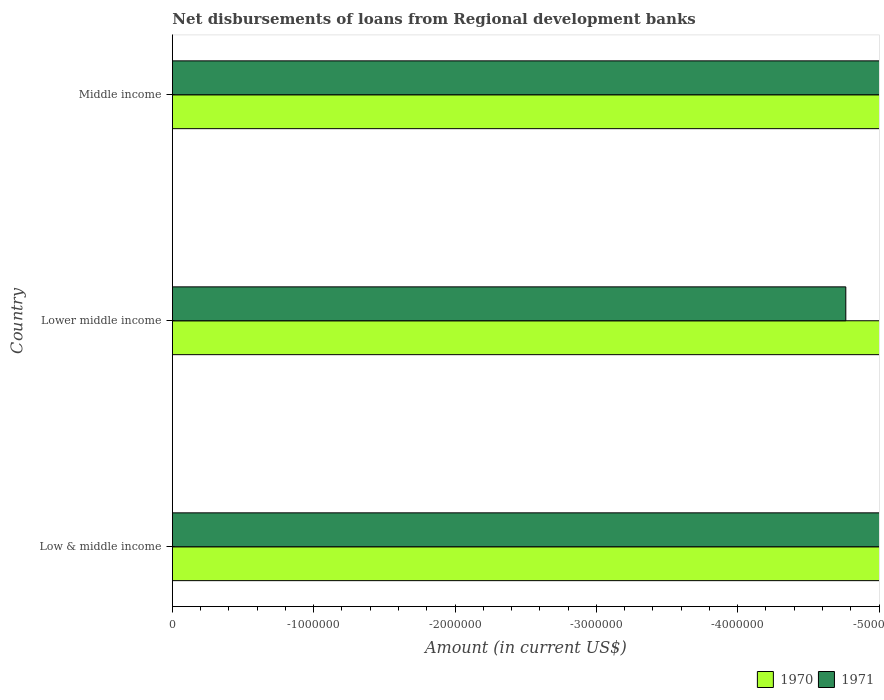How many different coloured bars are there?
Ensure brevity in your answer.  0. Are the number of bars per tick equal to the number of legend labels?
Offer a very short reply. No. How many bars are there on the 1st tick from the top?
Offer a very short reply. 0. What is the label of the 1st group of bars from the top?
Offer a very short reply. Middle income. What is the amount of disbursements of loans from regional development banks in 1970 in Middle income?
Your answer should be compact. 0. What is the difference between the amount of disbursements of loans from regional development banks in 1971 in Lower middle income and the amount of disbursements of loans from regional development banks in 1970 in Low & middle income?
Offer a terse response. 0. In how many countries, is the amount of disbursements of loans from regional development banks in 1971 greater than the average amount of disbursements of loans from regional development banks in 1971 taken over all countries?
Provide a succinct answer. 0. How many countries are there in the graph?
Give a very brief answer. 3. Does the graph contain any zero values?
Your response must be concise. Yes. Does the graph contain grids?
Make the answer very short. No. How many legend labels are there?
Provide a succinct answer. 2. How are the legend labels stacked?
Provide a short and direct response. Horizontal. What is the title of the graph?
Your response must be concise. Net disbursements of loans from Regional development banks. What is the label or title of the X-axis?
Give a very brief answer. Amount (in current US$). What is the label or title of the Y-axis?
Keep it short and to the point. Country. What is the Amount (in current US$) of 1970 in Low & middle income?
Ensure brevity in your answer.  0. What is the Amount (in current US$) of 1970 in Lower middle income?
Provide a short and direct response. 0. What is the Amount (in current US$) in 1971 in Lower middle income?
Your response must be concise. 0. What is the Amount (in current US$) in 1970 in Middle income?
Your response must be concise. 0. What is the Amount (in current US$) of 1971 in Middle income?
Your response must be concise. 0. What is the total Amount (in current US$) in 1970 in the graph?
Provide a short and direct response. 0. What is the total Amount (in current US$) of 1971 in the graph?
Provide a succinct answer. 0. What is the average Amount (in current US$) in 1970 per country?
Provide a succinct answer. 0. 